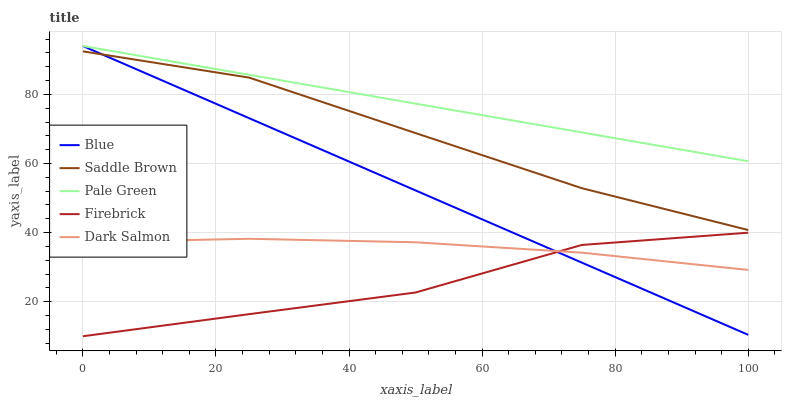Does Firebrick have the minimum area under the curve?
Answer yes or no. Yes. Does Pale Green have the maximum area under the curve?
Answer yes or no. Yes. Does Pale Green have the minimum area under the curve?
Answer yes or no. No. Does Firebrick have the maximum area under the curve?
Answer yes or no. No. Is Blue the smoothest?
Answer yes or no. Yes. Is Firebrick the roughest?
Answer yes or no. Yes. Is Pale Green the smoothest?
Answer yes or no. No. Is Pale Green the roughest?
Answer yes or no. No. Does Firebrick have the lowest value?
Answer yes or no. Yes. Does Pale Green have the lowest value?
Answer yes or no. No. Does Pale Green have the highest value?
Answer yes or no. Yes. Does Firebrick have the highest value?
Answer yes or no. No. Is Firebrick less than Saddle Brown?
Answer yes or no. Yes. Is Pale Green greater than Firebrick?
Answer yes or no. Yes. Does Blue intersect Firebrick?
Answer yes or no. Yes. Is Blue less than Firebrick?
Answer yes or no. No. Is Blue greater than Firebrick?
Answer yes or no. No. Does Firebrick intersect Saddle Brown?
Answer yes or no. No. 